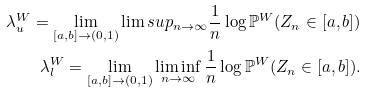<formula> <loc_0><loc_0><loc_500><loc_500>\lambda _ { u } ^ { W } = \lim _ { [ a , b ] \to ( 0 , 1 ) } \lim s u p _ { n \to \infty } \frac { 1 } { n } \log \mathbb { P } ^ { W } ( Z _ { n } \in [ a , b ] ) \\ \lambda _ { l } ^ { W } = \lim _ { [ a , b ] \to ( 0 , 1 ) } \liminf _ { n \to \infty } \frac { 1 } { n } \log \mathbb { P } ^ { W } ( Z _ { n } \in [ a , b ] ) .</formula> 